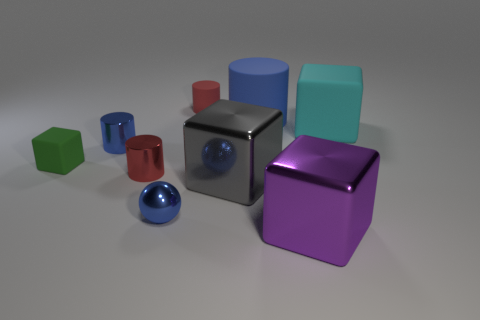Subtract all small rubber cylinders. How many cylinders are left? 3 Subtract all green cubes. How many cubes are left? 3 Subtract 1 blocks. How many blocks are left? 3 Add 1 purple metallic things. How many objects exist? 10 Subtract all cylinders. How many objects are left? 5 Subtract all cyan balls. How many purple cubes are left? 1 Subtract all shiny objects. Subtract all blue rubber blocks. How many objects are left? 4 Add 4 green things. How many green things are left? 5 Add 6 big gray shiny cubes. How many big gray shiny cubes exist? 7 Subtract 0 purple cylinders. How many objects are left? 9 